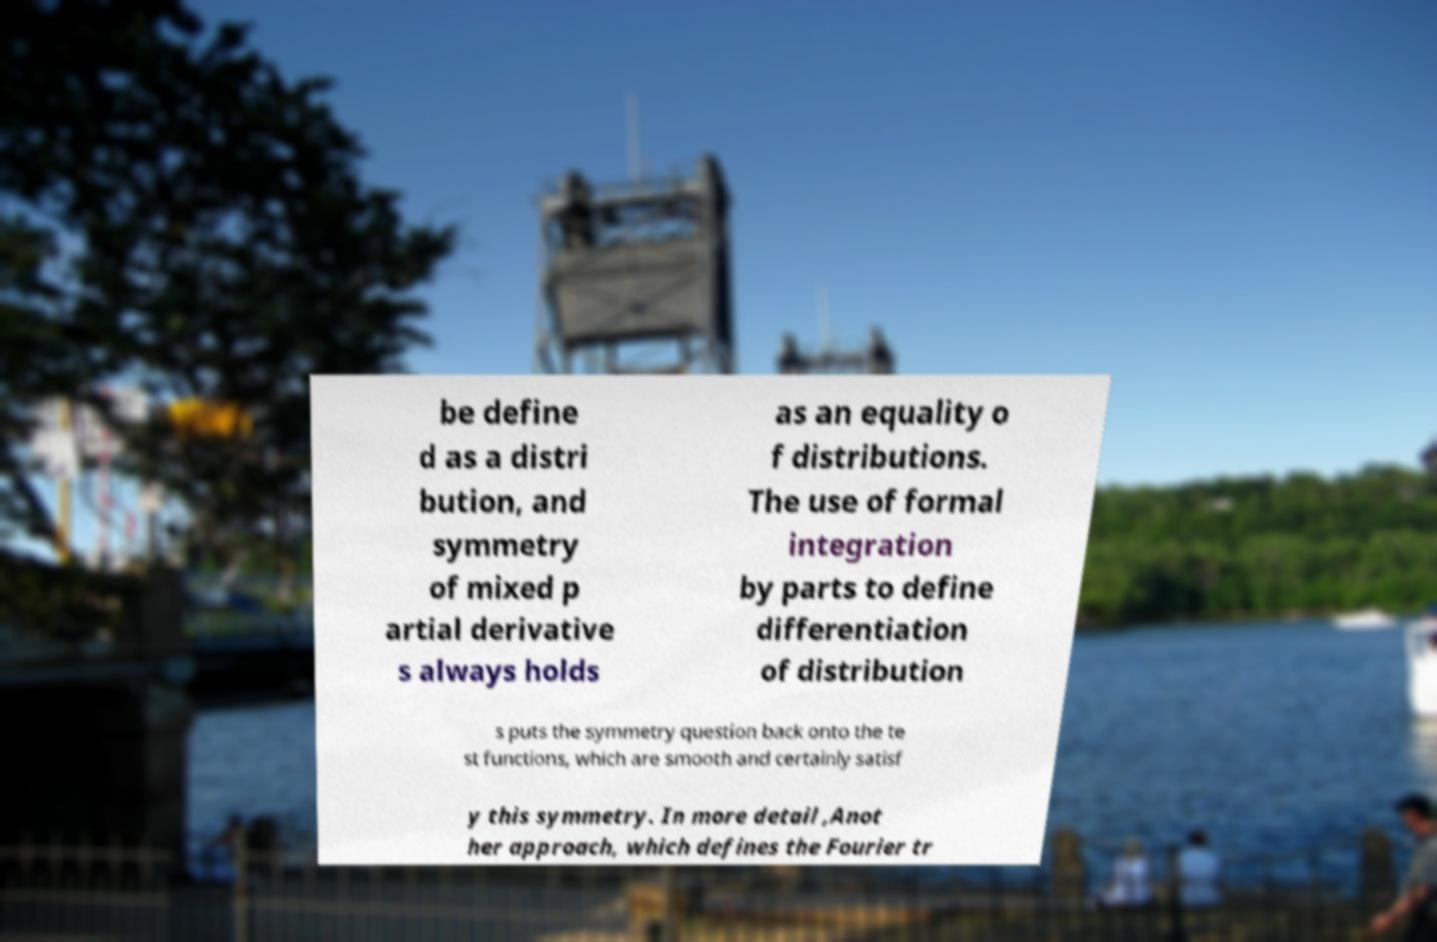Can you accurately transcribe the text from the provided image for me? be define d as a distri bution, and symmetry of mixed p artial derivative s always holds as an equality o f distributions. The use of formal integration by parts to define differentiation of distribution s puts the symmetry question back onto the te st functions, which are smooth and certainly satisf y this symmetry. In more detail ,Anot her approach, which defines the Fourier tr 